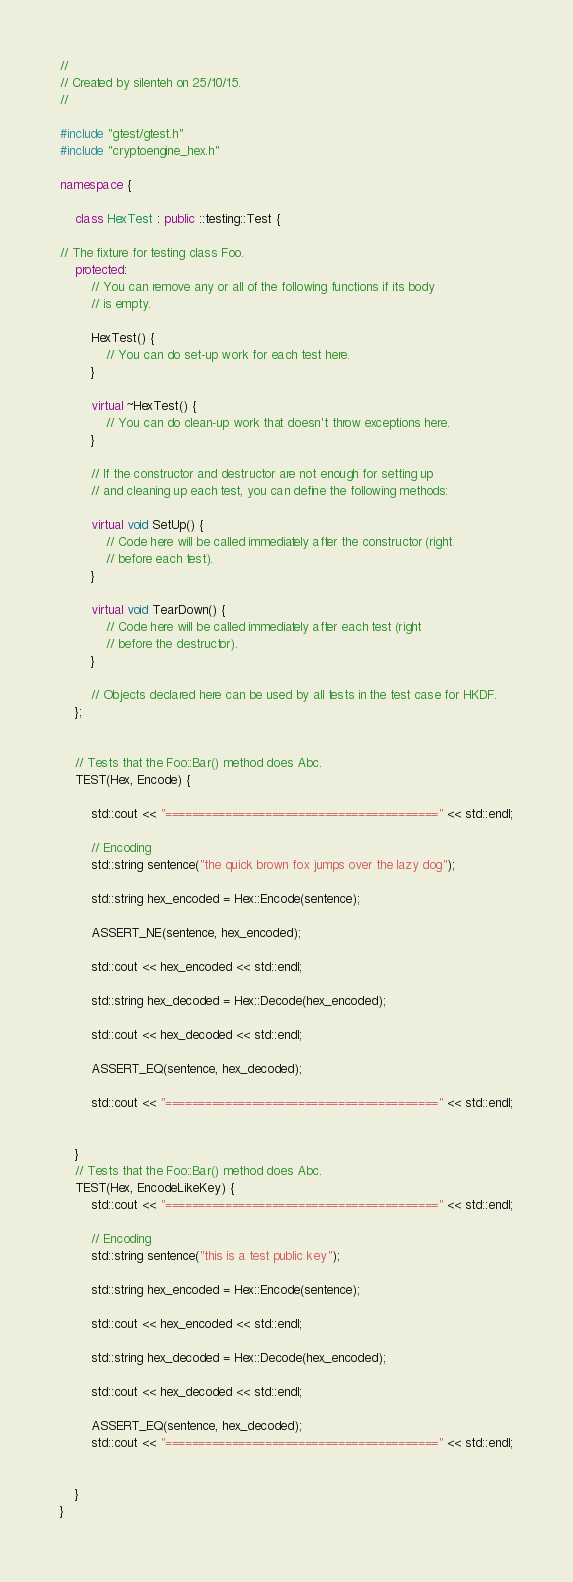Convert code to text. <code><loc_0><loc_0><loc_500><loc_500><_C++_>//
// Created by silenteh on 25/10/15.
//

#include "gtest/gtest.h"
#include "cryptoengine_hex.h"

namespace {

    class HexTest : public ::testing::Test {

// The fixture for testing class Foo.
    protected:
        // You can remove any or all of the following functions if its body
        // is empty.

        HexTest() {
            // You can do set-up work for each test here.
        }

        virtual ~HexTest() {
            // You can do clean-up work that doesn't throw exceptions here.
        }

        // If the constructor and destructor are not enough for setting up
        // and cleaning up each test, you can define the following methods:

        virtual void SetUp() {
            // Code here will be called immediately after the constructor (right
            // before each test).
        }

        virtual void TearDown() {
            // Code here will be called immediately after each test (right
            // before the destructor).
        }

        // Objects declared here can be used by all tests in the test case for HKDF.
    };


    // Tests that the Foo::Bar() method does Abc.
    TEST(Hex, Encode) {

        std::cout << "=========================================" << std::endl;

        // Encoding
        std::string sentence("the quick brown fox jumps over the lazy dog");

        std::string hex_encoded = Hex::Encode(sentence);

        ASSERT_NE(sentence, hex_encoded);

        std::cout << hex_encoded << std::endl;

        std::string hex_decoded = Hex::Decode(hex_encoded);

        std::cout << hex_decoded << std::endl;

        ASSERT_EQ(sentence, hex_decoded);

        std::cout << "=========================================" << std::endl;


    }
    // Tests that the Foo::Bar() method does Abc.
    TEST(Hex, EncodeLikeKey) {
        std::cout << "=========================================" << std::endl;

        // Encoding
        std::string sentence("this is a test public key");

        std::string hex_encoded = Hex::Encode(sentence);

        std::cout << hex_encoded << std::endl;

        std::string hex_decoded = Hex::Decode(hex_encoded);

        std::cout << hex_decoded << std::endl;

        ASSERT_EQ(sentence, hex_decoded);
        std::cout << "=========================================" << std::endl;


    }
}
</code> 